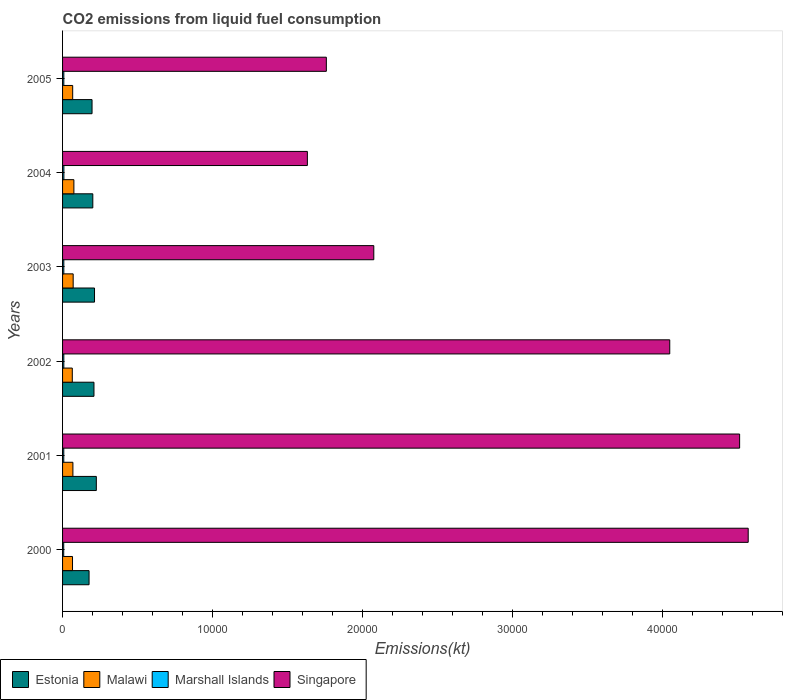Are the number of bars per tick equal to the number of legend labels?
Your answer should be compact. Yes. What is the label of the 4th group of bars from the top?
Your answer should be compact. 2002. In how many cases, is the number of bars for a given year not equal to the number of legend labels?
Your response must be concise. 0. What is the amount of CO2 emitted in Marshall Islands in 2002?
Give a very brief answer. 84.34. Across all years, what is the maximum amount of CO2 emitted in Malawi?
Make the answer very short. 755.4. Across all years, what is the minimum amount of CO2 emitted in Estonia?
Give a very brief answer. 1767.49. In which year was the amount of CO2 emitted in Marshall Islands maximum?
Offer a terse response. 2004. What is the total amount of CO2 emitted in Singapore in the graph?
Your response must be concise. 1.86e+05. What is the difference between the amount of CO2 emitted in Singapore in 2003 and that in 2004?
Ensure brevity in your answer.  4429.74. What is the difference between the amount of CO2 emitted in Estonia in 2003 and the amount of CO2 emitted in Marshall Islands in 2002?
Offer a very short reply. 2046.19. What is the average amount of CO2 emitted in Marshall Islands per year?
Offer a terse response. 83.12. In the year 2001, what is the difference between the amount of CO2 emitted in Malawi and amount of CO2 emitted in Estonia?
Ensure brevity in your answer.  -1562.14. What is the ratio of the amount of CO2 emitted in Marshall Islands in 2003 to that in 2004?
Your response must be concise. 0.96. Is the amount of CO2 emitted in Estonia in 2004 less than that in 2005?
Offer a very short reply. No. Is the difference between the amount of CO2 emitted in Malawi in 2000 and 2004 greater than the difference between the amount of CO2 emitted in Estonia in 2000 and 2004?
Provide a short and direct response. Yes. What is the difference between the highest and the second highest amount of CO2 emitted in Malawi?
Your answer should be compact. 47.67. What is the difference between the highest and the lowest amount of CO2 emitted in Malawi?
Ensure brevity in your answer.  106.34. Is the sum of the amount of CO2 emitted in Estonia in 2001 and 2004 greater than the maximum amount of CO2 emitted in Malawi across all years?
Provide a succinct answer. Yes. Is it the case that in every year, the sum of the amount of CO2 emitted in Singapore and amount of CO2 emitted in Marshall Islands is greater than the sum of amount of CO2 emitted in Estonia and amount of CO2 emitted in Malawi?
Your response must be concise. Yes. What does the 4th bar from the top in 2003 represents?
Ensure brevity in your answer.  Estonia. What does the 3rd bar from the bottom in 2005 represents?
Provide a succinct answer. Marshall Islands. Are all the bars in the graph horizontal?
Offer a very short reply. Yes. Does the graph contain grids?
Your answer should be very brief. No. How are the legend labels stacked?
Your answer should be very brief. Horizontal. What is the title of the graph?
Provide a succinct answer. CO2 emissions from liquid fuel consumption. Does "World" appear as one of the legend labels in the graph?
Your response must be concise. No. What is the label or title of the X-axis?
Offer a very short reply. Emissions(kt). What is the Emissions(kt) of Estonia in 2000?
Give a very brief answer. 1767.49. What is the Emissions(kt) of Malawi in 2000?
Offer a terse response. 663.73. What is the Emissions(kt) in Marshall Islands in 2000?
Your response must be concise. 77.01. What is the Emissions(kt) in Singapore in 2000?
Keep it short and to the point. 4.57e+04. What is the Emissions(kt) in Estonia in 2001?
Provide a succinct answer. 2251.54. What is the Emissions(kt) of Malawi in 2001?
Your answer should be very brief. 689.4. What is the Emissions(kt) of Marshall Islands in 2001?
Your answer should be compact. 80.67. What is the Emissions(kt) of Singapore in 2001?
Offer a very short reply. 4.52e+04. What is the Emissions(kt) of Estonia in 2002?
Ensure brevity in your answer.  2093.86. What is the Emissions(kt) of Malawi in 2002?
Your response must be concise. 649.06. What is the Emissions(kt) of Marshall Islands in 2002?
Give a very brief answer. 84.34. What is the Emissions(kt) of Singapore in 2002?
Provide a short and direct response. 4.05e+04. What is the Emissions(kt) of Estonia in 2003?
Make the answer very short. 2130.53. What is the Emissions(kt) of Malawi in 2003?
Ensure brevity in your answer.  707.73. What is the Emissions(kt) in Marshall Islands in 2003?
Provide a short and direct response. 84.34. What is the Emissions(kt) of Singapore in 2003?
Your answer should be compact. 2.08e+04. What is the Emissions(kt) in Estonia in 2004?
Ensure brevity in your answer.  2016.85. What is the Emissions(kt) of Malawi in 2004?
Provide a succinct answer. 755.4. What is the Emissions(kt) of Marshall Islands in 2004?
Your answer should be compact. 88.01. What is the Emissions(kt) in Singapore in 2004?
Make the answer very short. 1.63e+04. What is the Emissions(kt) of Estonia in 2005?
Your answer should be compact. 1965.51. What is the Emissions(kt) in Malawi in 2005?
Offer a very short reply. 674.73. What is the Emissions(kt) of Marshall Islands in 2005?
Give a very brief answer. 84.34. What is the Emissions(kt) of Singapore in 2005?
Keep it short and to the point. 1.76e+04. Across all years, what is the maximum Emissions(kt) in Estonia?
Give a very brief answer. 2251.54. Across all years, what is the maximum Emissions(kt) in Malawi?
Give a very brief answer. 755.4. Across all years, what is the maximum Emissions(kt) in Marshall Islands?
Provide a short and direct response. 88.01. Across all years, what is the maximum Emissions(kt) in Singapore?
Your answer should be very brief. 4.57e+04. Across all years, what is the minimum Emissions(kt) in Estonia?
Offer a very short reply. 1767.49. Across all years, what is the minimum Emissions(kt) in Malawi?
Your answer should be very brief. 649.06. Across all years, what is the minimum Emissions(kt) of Marshall Islands?
Keep it short and to the point. 77.01. Across all years, what is the minimum Emissions(kt) in Singapore?
Provide a succinct answer. 1.63e+04. What is the total Emissions(kt) in Estonia in the graph?
Your answer should be very brief. 1.22e+04. What is the total Emissions(kt) in Malawi in the graph?
Your response must be concise. 4140.04. What is the total Emissions(kt) of Marshall Islands in the graph?
Provide a short and direct response. 498.71. What is the total Emissions(kt) of Singapore in the graph?
Ensure brevity in your answer.  1.86e+05. What is the difference between the Emissions(kt) of Estonia in 2000 and that in 2001?
Keep it short and to the point. -484.04. What is the difference between the Emissions(kt) in Malawi in 2000 and that in 2001?
Make the answer very short. -25.67. What is the difference between the Emissions(kt) in Marshall Islands in 2000 and that in 2001?
Keep it short and to the point. -3.67. What is the difference between the Emissions(kt) of Singapore in 2000 and that in 2001?
Offer a terse response. 572.05. What is the difference between the Emissions(kt) in Estonia in 2000 and that in 2002?
Make the answer very short. -326.36. What is the difference between the Emissions(kt) in Malawi in 2000 and that in 2002?
Ensure brevity in your answer.  14.67. What is the difference between the Emissions(kt) in Marshall Islands in 2000 and that in 2002?
Offer a terse response. -7.33. What is the difference between the Emissions(kt) in Singapore in 2000 and that in 2002?
Provide a succinct answer. 5232.81. What is the difference between the Emissions(kt) in Estonia in 2000 and that in 2003?
Provide a succinct answer. -363.03. What is the difference between the Emissions(kt) in Malawi in 2000 and that in 2003?
Your response must be concise. -44. What is the difference between the Emissions(kt) in Marshall Islands in 2000 and that in 2003?
Provide a short and direct response. -7.33. What is the difference between the Emissions(kt) in Singapore in 2000 and that in 2003?
Ensure brevity in your answer.  2.50e+04. What is the difference between the Emissions(kt) in Estonia in 2000 and that in 2004?
Give a very brief answer. -249.36. What is the difference between the Emissions(kt) in Malawi in 2000 and that in 2004?
Provide a succinct answer. -91.67. What is the difference between the Emissions(kt) in Marshall Islands in 2000 and that in 2004?
Your answer should be very brief. -11. What is the difference between the Emissions(kt) in Singapore in 2000 and that in 2004?
Keep it short and to the point. 2.94e+04. What is the difference between the Emissions(kt) in Estonia in 2000 and that in 2005?
Offer a terse response. -198.02. What is the difference between the Emissions(kt) in Malawi in 2000 and that in 2005?
Keep it short and to the point. -11. What is the difference between the Emissions(kt) in Marshall Islands in 2000 and that in 2005?
Give a very brief answer. -7.33. What is the difference between the Emissions(kt) in Singapore in 2000 and that in 2005?
Give a very brief answer. 2.81e+04. What is the difference between the Emissions(kt) of Estonia in 2001 and that in 2002?
Your answer should be very brief. 157.68. What is the difference between the Emissions(kt) of Malawi in 2001 and that in 2002?
Your response must be concise. 40.34. What is the difference between the Emissions(kt) of Marshall Islands in 2001 and that in 2002?
Ensure brevity in your answer.  -3.67. What is the difference between the Emissions(kt) in Singapore in 2001 and that in 2002?
Keep it short and to the point. 4660.76. What is the difference between the Emissions(kt) in Estonia in 2001 and that in 2003?
Give a very brief answer. 121.01. What is the difference between the Emissions(kt) in Malawi in 2001 and that in 2003?
Provide a short and direct response. -18.34. What is the difference between the Emissions(kt) of Marshall Islands in 2001 and that in 2003?
Offer a very short reply. -3.67. What is the difference between the Emissions(kt) of Singapore in 2001 and that in 2003?
Keep it short and to the point. 2.44e+04. What is the difference between the Emissions(kt) of Estonia in 2001 and that in 2004?
Your answer should be very brief. 234.69. What is the difference between the Emissions(kt) in Malawi in 2001 and that in 2004?
Offer a terse response. -66.01. What is the difference between the Emissions(kt) of Marshall Islands in 2001 and that in 2004?
Ensure brevity in your answer.  -7.33. What is the difference between the Emissions(kt) in Singapore in 2001 and that in 2004?
Your answer should be compact. 2.88e+04. What is the difference between the Emissions(kt) in Estonia in 2001 and that in 2005?
Offer a very short reply. 286.03. What is the difference between the Emissions(kt) in Malawi in 2001 and that in 2005?
Give a very brief answer. 14.67. What is the difference between the Emissions(kt) in Marshall Islands in 2001 and that in 2005?
Offer a terse response. -3.67. What is the difference between the Emissions(kt) in Singapore in 2001 and that in 2005?
Provide a succinct answer. 2.76e+04. What is the difference between the Emissions(kt) in Estonia in 2002 and that in 2003?
Your response must be concise. -36.67. What is the difference between the Emissions(kt) of Malawi in 2002 and that in 2003?
Your answer should be compact. -58.67. What is the difference between the Emissions(kt) in Marshall Islands in 2002 and that in 2003?
Offer a very short reply. 0. What is the difference between the Emissions(kt) in Singapore in 2002 and that in 2003?
Offer a terse response. 1.97e+04. What is the difference between the Emissions(kt) in Estonia in 2002 and that in 2004?
Give a very brief answer. 77.01. What is the difference between the Emissions(kt) of Malawi in 2002 and that in 2004?
Your answer should be compact. -106.34. What is the difference between the Emissions(kt) of Marshall Islands in 2002 and that in 2004?
Give a very brief answer. -3.67. What is the difference between the Emissions(kt) of Singapore in 2002 and that in 2004?
Provide a succinct answer. 2.42e+04. What is the difference between the Emissions(kt) in Estonia in 2002 and that in 2005?
Give a very brief answer. 128.34. What is the difference between the Emissions(kt) in Malawi in 2002 and that in 2005?
Your response must be concise. -25.67. What is the difference between the Emissions(kt) of Singapore in 2002 and that in 2005?
Offer a very short reply. 2.29e+04. What is the difference between the Emissions(kt) of Estonia in 2003 and that in 2004?
Your answer should be very brief. 113.68. What is the difference between the Emissions(kt) in Malawi in 2003 and that in 2004?
Provide a short and direct response. -47.67. What is the difference between the Emissions(kt) of Marshall Islands in 2003 and that in 2004?
Provide a short and direct response. -3.67. What is the difference between the Emissions(kt) of Singapore in 2003 and that in 2004?
Your response must be concise. 4429.74. What is the difference between the Emissions(kt) in Estonia in 2003 and that in 2005?
Provide a short and direct response. 165.01. What is the difference between the Emissions(kt) in Malawi in 2003 and that in 2005?
Offer a terse response. 33. What is the difference between the Emissions(kt) of Singapore in 2003 and that in 2005?
Give a very brief answer. 3164.62. What is the difference between the Emissions(kt) of Estonia in 2004 and that in 2005?
Make the answer very short. 51.34. What is the difference between the Emissions(kt) in Malawi in 2004 and that in 2005?
Offer a terse response. 80.67. What is the difference between the Emissions(kt) in Marshall Islands in 2004 and that in 2005?
Your answer should be compact. 3.67. What is the difference between the Emissions(kt) of Singapore in 2004 and that in 2005?
Make the answer very short. -1265.12. What is the difference between the Emissions(kt) of Estonia in 2000 and the Emissions(kt) of Malawi in 2001?
Offer a very short reply. 1078.1. What is the difference between the Emissions(kt) in Estonia in 2000 and the Emissions(kt) in Marshall Islands in 2001?
Provide a short and direct response. 1686.82. What is the difference between the Emissions(kt) of Estonia in 2000 and the Emissions(kt) of Singapore in 2001?
Your answer should be very brief. -4.34e+04. What is the difference between the Emissions(kt) in Malawi in 2000 and the Emissions(kt) in Marshall Islands in 2001?
Keep it short and to the point. 583.05. What is the difference between the Emissions(kt) in Malawi in 2000 and the Emissions(kt) in Singapore in 2001?
Offer a terse response. -4.45e+04. What is the difference between the Emissions(kt) of Marshall Islands in 2000 and the Emissions(kt) of Singapore in 2001?
Make the answer very short. -4.51e+04. What is the difference between the Emissions(kt) of Estonia in 2000 and the Emissions(kt) of Malawi in 2002?
Give a very brief answer. 1118.43. What is the difference between the Emissions(kt) in Estonia in 2000 and the Emissions(kt) in Marshall Islands in 2002?
Your answer should be very brief. 1683.15. What is the difference between the Emissions(kt) of Estonia in 2000 and the Emissions(kt) of Singapore in 2002?
Your response must be concise. -3.87e+04. What is the difference between the Emissions(kt) in Malawi in 2000 and the Emissions(kt) in Marshall Islands in 2002?
Make the answer very short. 579.39. What is the difference between the Emissions(kt) of Malawi in 2000 and the Emissions(kt) of Singapore in 2002?
Ensure brevity in your answer.  -3.98e+04. What is the difference between the Emissions(kt) in Marshall Islands in 2000 and the Emissions(kt) in Singapore in 2002?
Provide a succinct answer. -4.04e+04. What is the difference between the Emissions(kt) in Estonia in 2000 and the Emissions(kt) in Malawi in 2003?
Provide a succinct answer. 1059.76. What is the difference between the Emissions(kt) of Estonia in 2000 and the Emissions(kt) of Marshall Islands in 2003?
Provide a succinct answer. 1683.15. What is the difference between the Emissions(kt) in Estonia in 2000 and the Emissions(kt) in Singapore in 2003?
Your answer should be very brief. -1.90e+04. What is the difference between the Emissions(kt) in Malawi in 2000 and the Emissions(kt) in Marshall Islands in 2003?
Keep it short and to the point. 579.39. What is the difference between the Emissions(kt) in Malawi in 2000 and the Emissions(kt) in Singapore in 2003?
Provide a succinct answer. -2.01e+04. What is the difference between the Emissions(kt) in Marshall Islands in 2000 and the Emissions(kt) in Singapore in 2003?
Give a very brief answer. -2.07e+04. What is the difference between the Emissions(kt) of Estonia in 2000 and the Emissions(kt) of Malawi in 2004?
Ensure brevity in your answer.  1012.09. What is the difference between the Emissions(kt) in Estonia in 2000 and the Emissions(kt) in Marshall Islands in 2004?
Your response must be concise. 1679.49. What is the difference between the Emissions(kt) in Estonia in 2000 and the Emissions(kt) in Singapore in 2004?
Your response must be concise. -1.46e+04. What is the difference between the Emissions(kt) in Malawi in 2000 and the Emissions(kt) in Marshall Islands in 2004?
Provide a short and direct response. 575.72. What is the difference between the Emissions(kt) of Malawi in 2000 and the Emissions(kt) of Singapore in 2004?
Make the answer very short. -1.57e+04. What is the difference between the Emissions(kt) of Marshall Islands in 2000 and the Emissions(kt) of Singapore in 2004?
Your answer should be compact. -1.62e+04. What is the difference between the Emissions(kt) of Estonia in 2000 and the Emissions(kt) of Malawi in 2005?
Your response must be concise. 1092.77. What is the difference between the Emissions(kt) in Estonia in 2000 and the Emissions(kt) in Marshall Islands in 2005?
Provide a succinct answer. 1683.15. What is the difference between the Emissions(kt) of Estonia in 2000 and the Emissions(kt) of Singapore in 2005?
Keep it short and to the point. -1.58e+04. What is the difference between the Emissions(kt) of Malawi in 2000 and the Emissions(kt) of Marshall Islands in 2005?
Give a very brief answer. 579.39. What is the difference between the Emissions(kt) of Malawi in 2000 and the Emissions(kt) of Singapore in 2005?
Make the answer very short. -1.69e+04. What is the difference between the Emissions(kt) of Marshall Islands in 2000 and the Emissions(kt) of Singapore in 2005?
Keep it short and to the point. -1.75e+04. What is the difference between the Emissions(kt) of Estonia in 2001 and the Emissions(kt) of Malawi in 2002?
Offer a terse response. 1602.48. What is the difference between the Emissions(kt) of Estonia in 2001 and the Emissions(kt) of Marshall Islands in 2002?
Offer a very short reply. 2167.2. What is the difference between the Emissions(kt) of Estonia in 2001 and the Emissions(kt) of Singapore in 2002?
Ensure brevity in your answer.  -3.82e+04. What is the difference between the Emissions(kt) of Malawi in 2001 and the Emissions(kt) of Marshall Islands in 2002?
Your answer should be very brief. 605.05. What is the difference between the Emissions(kt) of Malawi in 2001 and the Emissions(kt) of Singapore in 2002?
Provide a succinct answer. -3.98e+04. What is the difference between the Emissions(kt) of Marshall Islands in 2001 and the Emissions(kt) of Singapore in 2002?
Your response must be concise. -4.04e+04. What is the difference between the Emissions(kt) of Estonia in 2001 and the Emissions(kt) of Malawi in 2003?
Offer a very short reply. 1543.81. What is the difference between the Emissions(kt) of Estonia in 2001 and the Emissions(kt) of Marshall Islands in 2003?
Ensure brevity in your answer.  2167.2. What is the difference between the Emissions(kt) in Estonia in 2001 and the Emissions(kt) in Singapore in 2003?
Provide a succinct answer. -1.85e+04. What is the difference between the Emissions(kt) of Malawi in 2001 and the Emissions(kt) of Marshall Islands in 2003?
Offer a very short reply. 605.05. What is the difference between the Emissions(kt) in Malawi in 2001 and the Emissions(kt) in Singapore in 2003?
Make the answer very short. -2.01e+04. What is the difference between the Emissions(kt) in Marshall Islands in 2001 and the Emissions(kt) in Singapore in 2003?
Provide a short and direct response. -2.07e+04. What is the difference between the Emissions(kt) in Estonia in 2001 and the Emissions(kt) in Malawi in 2004?
Offer a terse response. 1496.14. What is the difference between the Emissions(kt) in Estonia in 2001 and the Emissions(kt) in Marshall Islands in 2004?
Keep it short and to the point. 2163.53. What is the difference between the Emissions(kt) in Estonia in 2001 and the Emissions(kt) in Singapore in 2004?
Provide a succinct answer. -1.41e+04. What is the difference between the Emissions(kt) of Malawi in 2001 and the Emissions(kt) of Marshall Islands in 2004?
Ensure brevity in your answer.  601.39. What is the difference between the Emissions(kt) of Malawi in 2001 and the Emissions(kt) of Singapore in 2004?
Your answer should be compact. -1.56e+04. What is the difference between the Emissions(kt) in Marshall Islands in 2001 and the Emissions(kt) in Singapore in 2004?
Make the answer very short. -1.62e+04. What is the difference between the Emissions(kt) in Estonia in 2001 and the Emissions(kt) in Malawi in 2005?
Offer a terse response. 1576.81. What is the difference between the Emissions(kt) in Estonia in 2001 and the Emissions(kt) in Marshall Islands in 2005?
Provide a short and direct response. 2167.2. What is the difference between the Emissions(kt) of Estonia in 2001 and the Emissions(kt) of Singapore in 2005?
Offer a very short reply. -1.53e+04. What is the difference between the Emissions(kt) in Malawi in 2001 and the Emissions(kt) in Marshall Islands in 2005?
Make the answer very short. 605.05. What is the difference between the Emissions(kt) in Malawi in 2001 and the Emissions(kt) in Singapore in 2005?
Ensure brevity in your answer.  -1.69e+04. What is the difference between the Emissions(kt) of Marshall Islands in 2001 and the Emissions(kt) of Singapore in 2005?
Your answer should be compact. -1.75e+04. What is the difference between the Emissions(kt) in Estonia in 2002 and the Emissions(kt) in Malawi in 2003?
Offer a terse response. 1386.13. What is the difference between the Emissions(kt) in Estonia in 2002 and the Emissions(kt) in Marshall Islands in 2003?
Offer a very short reply. 2009.52. What is the difference between the Emissions(kt) of Estonia in 2002 and the Emissions(kt) of Singapore in 2003?
Make the answer very short. -1.87e+04. What is the difference between the Emissions(kt) in Malawi in 2002 and the Emissions(kt) in Marshall Islands in 2003?
Keep it short and to the point. 564.72. What is the difference between the Emissions(kt) of Malawi in 2002 and the Emissions(kt) of Singapore in 2003?
Ensure brevity in your answer.  -2.01e+04. What is the difference between the Emissions(kt) of Marshall Islands in 2002 and the Emissions(kt) of Singapore in 2003?
Offer a very short reply. -2.07e+04. What is the difference between the Emissions(kt) in Estonia in 2002 and the Emissions(kt) in Malawi in 2004?
Provide a succinct answer. 1338.45. What is the difference between the Emissions(kt) in Estonia in 2002 and the Emissions(kt) in Marshall Islands in 2004?
Offer a terse response. 2005.85. What is the difference between the Emissions(kt) of Estonia in 2002 and the Emissions(kt) of Singapore in 2004?
Offer a very short reply. -1.42e+04. What is the difference between the Emissions(kt) of Malawi in 2002 and the Emissions(kt) of Marshall Islands in 2004?
Make the answer very short. 561.05. What is the difference between the Emissions(kt) in Malawi in 2002 and the Emissions(kt) in Singapore in 2004?
Your response must be concise. -1.57e+04. What is the difference between the Emissions(kt) in Marshall Islands in 2002 and the Emissions(kt) in Singapore in 2004?
Your response must be concise. -1.62e+04. What is the difference between the Emissions(kt) in Estonia in 2002 and the Emissions(kt) in Malawi in 2005?
Make the answer very short. 1419.13. What is the difference between the Emissions(kt) of Estonia in 2002 and the Emissions(kt) of Marshall Islands in 2005?
Keep it short and to the point. 2009.52. What is the difference between the Emissions(kt) of Estonia in 2002 and the Emissions(kt) of Singapore in 2005?
Offer a terse response. -1.55e+04. What is the difference between the Emissions(kt) of Malawi in 2002 and the Emissions(kt) of Marshall Islands in 2005?
Give a very brief answer. 564.72. What is the difference between the Emissions(kt) of Malawi in 2002 and the Emissions(kt) of Singapore in 2005?
Make the answer very short. -1.69e+04. What is the difference between the Emissions(kt) in Marshall Islands in 2002 and the Emissions(kt) in Singapore in 2005?
Make the answer very short. -1.75e+04. What is the difference between the Emissions(kt) in Estonia in 2003 and the Emissions(kt) in Malawi in 2004?
Provide a succinct answer. 1375.12. What is the difference between the Emissions(kt) in Estonia in 2003 and the Emissions(kt) in Marshall Islands in 2004?
Your answer should be very brief. 2042.52. What is the difference between the Emissions(kt) of Estonia in 2003 and the Emissions(kt) of Singapore in 2004?
Keep it short and to the point. -1.42e+04. What is the difference between the Emissions(kt) in Malawi in 2003 and the Emissions(kt) in Marshall Islands in 2004?
Your response must be concise. 619.72. What is the difference between the Emissions(kt) in Malawi in 2003 and the Emissions(kt) in Singapore in 2004?
Your answer should be compact. -1.56e+04. What is the difference between the Emissions(kt) in Marshall Islands in 2003 and the Emissions(kt) in Singapore in 2004?
Offer a terse response. -1.62e+04. What is the difference between the Emissions(kt) in Estonia in 2003 and the Emissions(kt) in Malawi in 2005?
Keep it short and to the point. 1455.8. What is the difference between the Emissions(kt) in Estonia in 2003 and the Emissions(kt) in Marshall Islands in 2005?
Your answer should be compact. 2046.19. What is the difference between the Emissions(kt) of Estonia in 2003 and the Emissions(kt) of Singapore in 2005?
Your response must be concise. -1.55e+04. What is the difference between the Emissions(kt) in Malawi in 2003 and the Emissions(kt) in Marshall Islands in 2005?
Your response must be concise. 623.39. What is the difference between the Emissions(kt) in Malawi in 2003 and the Emissions(kt) in Singapore in 2005?
Provide a succinct answer. -1.69e+04. What is the difference between the Emissions(kt) of Marshall Islands in 2003 and the Emissions(kt) of Singapore in 2005?
Your answer should be very brief. -1.75e+04. What is the difference between the Emissions(kt) in Estonia in 2004 and the Emissions(kt) in Malawi in 2005?
Make the answer very short. 1342.12. What is the difference between the Emissions(kt) in Estonia in 2004 and the Emissions(kt) in Marshall Islands in 2005?
Make the answer very short. 1932.51. What is the difference between the Emissions(kt) in Estonia in 2004 and the Emissions(kt) in Singapore in 2005?
Make the answer very short. -1.56e+04. What is the difference between the Emissions(kt) in Malawi in 2004 and the Emissions(kt) in Marshall Islands in 2005?
Provide a short and direct response. 671.06. What is the difference between the Emissions(kt) in Malawi in 2004 and the Emissions(kt) in Singapore in 2005?
Make the answer very short. -1.68e+04. What is the difference between the Emissions(kt) in Marshall Islands in 2004 and the Emissions(kt) in Singapore in 2005?
Your answer should be compact. -1.75e+04. What is the average Emissions(kt) of Estonia per year?
Ensure brevity in your answer.  2037.63. What is the average Emissions(kt) of Malawi per year?
Make the answer very short. 690.01. What is the average Emissions(kt) of Marshall Islands per year?
Offer a very short reply. 83.12. What is the average Emissions(kt) of Singapore per year?
Ensure brevity in your answer.  3.10e+04. In the year 2000, what is the difference between the Emissions(kt) of Estonia and Emissions(kt) of Malawi?
Ensure brevity in your answer.  1103.77. In the year 2000, what is the difference between the Emissions(kt) in Estonia and Emissions(kt) in Marshall Islands?
Your response must be concise. 1690.49. In the year 2000, what is the difference between the Emissions(kt) in Estonia and Emissions(kt) in Singapore?
Ensure brevity in your answer.  -4.40e+04. In the year 2000, what is the difference between the Emissions(kt) in Malawi and Emissions(kt) in Marshall Islands?
Ensure brevity in your answer.  586.72. In the year 2000, what is the difference between the Emissions(kt) in Malawi and Emissions(kt) in Singapore?
Your answer should be very brief. -4.51e+04. In the year 2000, what is the difference between the Emissions(kt) in Marshall Islands and Emissions(kt) in Singapore?
Offer a very short reply. -4.56e+04. In the year 2001, what is the difference between the Emissions(kt) of Estonia and Emissions(kt) of Malawi?
Your answer should be compact. 1562.14. In the year 2001, what is the difference between the Emissions(kt) of Estonia and Emissions(kt) of Marshall Islands?
Ensure brevity in your answer.  2170.86. In the year 2001, what is the difference between the Emissions(kt) in Estonia and Emissions(kt) in Singapore?
Keep it short and to the point. -4.29e+04. In the year 2001, what is the difference between the Emissions(kt) in Malawi and Emissions(kt) in Marshall Islands?
Provide a succinct answer. 608.72. In the year 2001, what is the difference between the Emissions(kt) of Malawi and Emissions(kt) of Singapore?
Keep it short and to the point. -4.45e+04. In the year 2001, what is the difference between the Emissions(kt) of Marshall Islands and Emissions(kt) of Singapore?
Your answer should be very brief. -4.51e+04. In the year 2002, what is the difference between the Emissions(kt) in Estonia and Emissions(kt) in Malawi?
Your answer should be compact. 1444.8. In the year 2002, what is the difference between the Emissions(kt) in Estonia and Emissions(kt) in Marshall Islands?
Your response must be concise. 2009.52. In the year 2002, what is the difference between the Emissions(kt) in Estonia and Emissions(kt) in Singapore?
Your response must be concise. -3.84e+04. In the year 2002, what is the difference between the Emissions(kt) of Malawi and Emissions(kt) of Marshall Islands?
Offer a very short reply. 564.72. In the year 2002, what is the difference between the Emissions(kt) in Malawi and Emissions(kt) in Singapore?
Your answer should be very brief. -3.98e+04. In the year 2002, what is the difference between the Emissions(kt) of Marshall Islands and Emissions(kt) of Singapore?
Your response must be concise. -4.04e+04. In the year 2003, what is the difference between the Emissions(kt) in Estonia and Emissions(kt) in Malawi?
Your response must be concise. 1422.8. In the year 2003, what is the difference between the Emissions(kt) of Estonia and Emissions(kt) of Marshall Islands?
Make the answer very short. 2046.19. In the year 2003, what is the difference between the Emissions(kt) in Estonia and Emissions(kt) in Singapore?
Provide a succinct answer. -1.86e+04. In the year 2003, what is the difference between the Emissions(kt) in Malawi and Emissions(kt) in Marshall Islands?
Your response must be concise. 623.39. In the year 2003, what is the difference between the Emissions(kt) of Malawi and Emissions(kt) of Singapore?
Offer a very short reply. -2.00e+04. In the year 2003, what is the difference between the Emissions(kt) of Marshall Islands and Emissions(kt) of Singapore?
Your response must be concise. -2.07e+04. In the year 2004, what is the difference between the Emissions(kt) in Estonia and Emissions(kt) in Malawi?
Offer a terse response. 1261.45. In the year 2004, what is the difference between the Emissions(kt) of Estonia and Emissions(kt) of Marshall Islands?
Offer a terse response. 1928.84. In the year 2004, what is the difference between the Emissions(kt) in Estonia and Emissions(kt) in Singapore?
Give a very brief answer. -1.43e+04. In the year 2004, what is the difference between the Emissions(kt) in Malawi and Emissions(kt) in Marshall Islands?
Your answer should be very brief. 667.39. In the year 2004, what is the difference between the Emissions(kt) in Malawi and Emissions(kt) in Singapore?
Your answer should be compact. -1.56e+04. In the year 2004, what is the difference between the Emissions(kt) in Marshall Islands and Emissions(kt) in Singapore?
Give a very brief answer. -1.62e+04. In the year 2005, what is the difference between the Emissions(kt) in Estonia and Emissions(kt) in Malawi?
Give a very brief answer. 1290.78. In the year 2005, what is the difference between the Emissions(kt) of Estonia and Emissions(kt) of Marshall Islands?
Offer a terse response. 1881.17. In the year 2005, what is the difference between the Emissions(kt) of Estonia and Emissions(kt) of Singapore?
Your answer should be compact. -1.56e+04. In the year 2005, what is the difference between the Emissions(kt) in Malawi and Emissions(kt) in Marshall Islands?
Make the answer very short. 590.39. In the year 2005, what is the difference between the Emissions(kt) of Malawi and Emissions(kt) of Singapore?
Your response must be concise. -1.69e+04. In the year 2005, what is the difference between the Emissions(kt) of Marshall Islands and Emissions(kt) of Singapore?
Your response must be concise. -1.75e+04. What is the ratio of the Emissions(kt) in Estonia in 2000 to that in 2001?
Offer a terse response. 0.79. What is the ratio of the Emissions(kt) in Malawi in 2000 to that in 2001?
Offer a very short reply. 0.96. What is the ratio of the Emissions(kt) of Marshall Islands in 2000 to that in 2001?
Your answer should be very brief. 0.95. What is the ratio of the Emissions(kt) of Singapore in 2000 to that in 2001?
Offer a terse response. 1.01. What is the ratio of the Emissions(kt) in Estonia in 2000 to that in 2002?
Keep it short and to the point. 0.84. What is the ratio of the Emissions(kt) in Malawi in 2000 to that in 2002?
Ensure brevity in your answer.  1.02. What is the ratio of the Emissions(kt) in Marshall Islands in 2000 to that in 2002?
Make the answer very short. 0.91. What is the ratio of the Emissions(kt) of Singapore in 2000 to that in 2002?
Give a very brief answer. 1.13. What is the ratio of the Emissions(kt) in Estonia in 2000 to that in 2003?
Keep it short and to the point. 0.83. What is the ratio of the Emissions(kt) of Malawi in 2000 to that in 2003?
Make the answer very short. 0.94. What is the ratio of the Emissions(kt) in Singapore in 2000 to that in 2003?
Ensure brevity in your answer.  2.2. What is the ratio of the Emissions(kt) of Estonia in 2000 to that in 2004?
Provide a short and direct response. 0.88. What is the ratio of the Emissions(kt) of Malawi in 2000 to that in 2004?
Ensure brevity in your answer.  0.88. What is the ratio of the Emissions(kt) of Marshall Islands in 2000 to that in 2004?
Your response must be concise. 0.88. What is the ratio of the Emissions(kt) in Singapore in 2000 to that in 2004?
Your answer should be compact. 2.8. What is the ratio of the Emissions(kt) of Estonia in 2000 to that in 2005?
Your answer should be very brief. 0.9. What is the ratio of the Emissions(kt) of Malawi in 2000 to that in 2005?
Your answer should be compact. 0.98. What is the ratio of the Emissions(kt) in Singapore in 2000 to that in 2005?
Provide a succinct answer. 2.6. What is the ratio of the Emissions(kt) of Estonia in 2001 to that in 2002?
Your answer should be compact. 1.08. What is the ratio of the Emissions(kt) in Malawi in 2001 to that in 2002?
Provide a succinct answer. 1.06. What is the ratio of the Emissions(kt) in Marshall Islands in 2001 to that in 2002?
Your answer should be compact. 0.96. What is the ratio of the Emissions(kt) in Singapore in 2001 to that in 2002?
Provide a short and direct response. 1.12. What is the ratio of the Emissions(kt) in Estonia in 2001 to that in 2003?
Your answer should be compact. 1.06. What is the ratio of the Emissions(kt) in Malawi in 2001 to that in 2003?
Offer a very short reply. 0.97. What is the ratio of the Emissions(kt) in Marshall Islands in 2001 to that in 2003?
Make the answer very short. 0.96. What is the ratio of the Emissions(kt) of Singapore in 2001 to that in 2003?
Ensure brevity in your answer.  2.18. What is the ratio of the Emissions(kt) of Estonia in 2001 to that in 2004?
Give a very brief answer. 1.12. What is the ratio of the Emissions(kt) in Malawi in 2001 to that in 2004?
Provide a succinct answer. 0.91. What is the ratio of the Emissions(kt) in Singapore in 2001 to that in 2004?
Your answer should be compact. 2.77. What is the ratio of the Emissions(kt) in Estonia in 2001 to that in 2005?
Offer a very short reply. 1.15. What is the ratio of the Emissions(kt) of Malawi in 2001 to that in 2005?
Keep it short and to the point. 1.02. What is the ratio of the Emissions(kt) of Marshall Islands in 2001 to that in 2005?
Offer a terse response. 0.96. What is the ratio of the Emissions(kt) in Singapore in 2001 to that in 2005?
Give a very brief answer. 2.57. What is the ratio of the Emissions(kt) in Estonia in 2002 to that in 2003?
Your response must be concise. 0.98. What is the ratio of the Emissions(kt) in Malawi in 2002 to that in 2003?
Provide a succinct answer. 0.92. What is the ratio of the Emissions(kt) in Singapore in 2002 to that in 2003?
Ensure brevity in your answer.  1.95. What is the ratio of the Emissions(kt) of Estonia in 2002 to that in 2004?
Make the answer very short. 1.04. What is the ratio of the Emissions(kt) in Malawi in 2002 to that in 2004?
Make the answer very short. 0.86. What is the ratio of the Emissions(kt) of Marshall Islands in 2002 to that in 2004?
Give a very brief answer. 0.96. What is the ratio of the Emissions(kt) of Singapore in 2002 to that in 2004?
Your answer should be very brief. 2.48. What is the ratio of the Emissions(kt) of Estonia in 2002 to that in 2005?
Offer a terse response. 1.07. What is the ratio of the Emissions(kt) in Singapore in 2002 to that in 2005?
Provide a short and direct response. 2.3. What is the ratio of the Emissions(kt) of Estonia in 2003 to that in 2004?
Give a very brief answer. 1.06. What is the ratio of the Emissions(kt) of Malawi in 2003 to that in 2004?
Keep it short and to the point. 0.94. What is the ratio of the Emissions(kt) of Singapore in 2003 to that in 2004?
Your answer should be compact. 1.27. What is the ratio of the Emissions(kt) in Estonia in 2003 to that in 2005?
Keep it short and to the point. 1.08. What is the ratio of the Emissions(kt) of Malawi in 2003 to that in 2005?
Your answer should be very brief. 1.05. What is the ratio of the Emissions(kt) of Marshall Islands in 2003 to that in 2005?
Your response must be concise. 1. What is the ratio of the Emissions(kt) in Singapore in 2003 to that in 2005?
Your answer should be very brief. 1.18. What is the ratio of the Emissions(kt) of Estonia in 2004 to that in 2005?
Your response must be concise. 1.03. What is the ratio of the Emissions(kt) in Malawi in 2004 to that in 2005?
Give a very brief answer. 1.12. What is the ratio of the Emissions(kt) of Marshall Islands in 2004 to that in 2005?
Give a very brief answer. 1.04. What is the ratio of the Emissions(kt) of Singapore in 2004 to that in 2005?
Provide a short and direct response. 0.93. What is the difference between the highest and the second highest Emissions(kt) in Estonia?
Make the answer very short. 121.01. What is the difference between the highest and the second highest Emissions(kt) of Malawi?
Give a very brief answer. 47.67. What is the difference between the highest and the second highest Emissions(kt) in Marshall Islands?
Offer a very short reply. 3.67. What is the difference between the highest and the second highest Emissions(kt) of Singapore?
Provide a short and direct response. 572.05. What is the difference between the highest and the lowest Emissions(kt) of Estonia?
Ensure brevity in your answer.  484.04. What is the difference between the highest and the lowest Emissions(kt) of Malawi?
Provide a succinct answer. 106.34. What is the difference between the highest and the lowest Emissions(kt) in Marshall Islands?
Provide a short and direct response. 11. What is the difference between the highest and the lowest Emissions(kt) in Singapore?
Make the answer very short. 2.94e+04. 